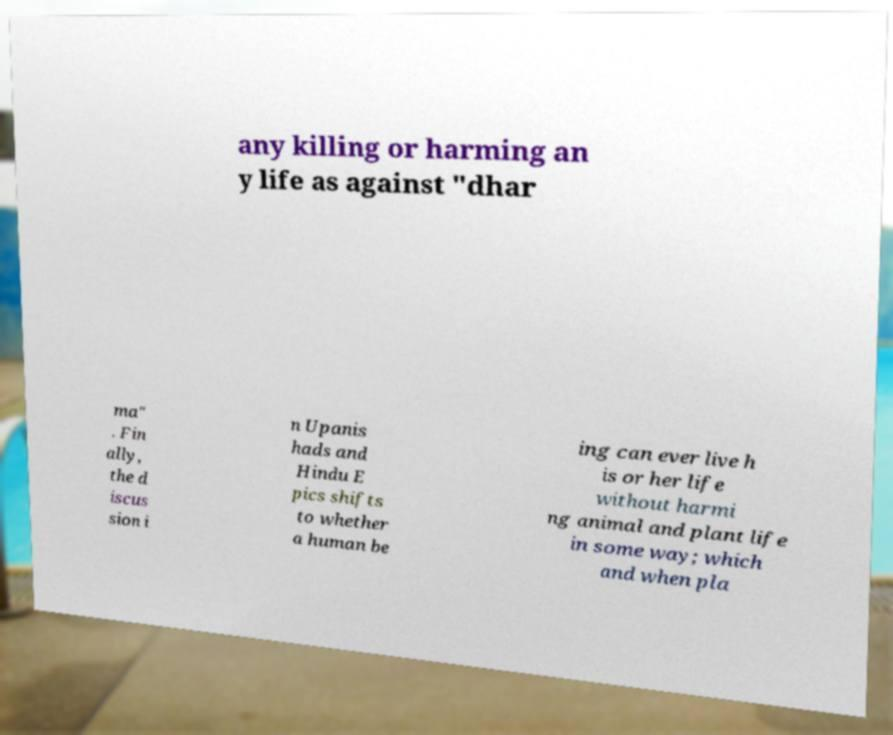Please identify and transcribe the text found in this image. any killing or harming an y life as against "dhar ma" . Fin ally, the d iscus sion i n Upanis hads and Hindu E pics shifts to whether a human be ing can ever live h is or her life without harmi ng animal and plant life in some way; which and when pla 